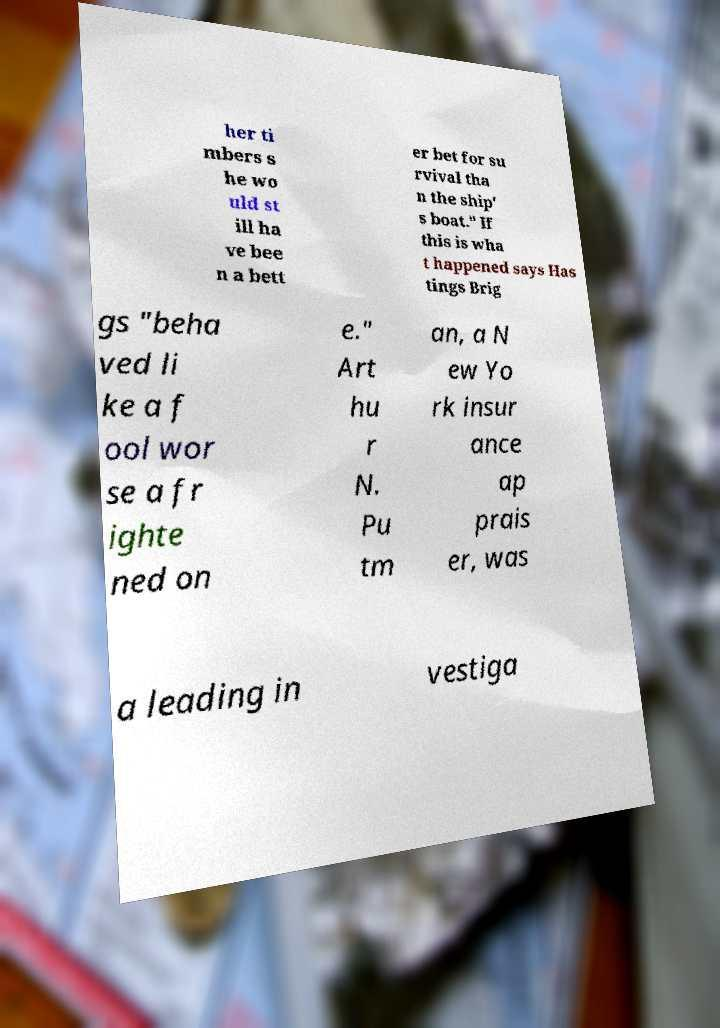What messages or text are displayed in this image? I need them in a readable, typed format. her ti mbers s he wo uld st ill ha ve bee n a bett er bet for su rvival tha n the ship' s boat." If this is wha t happened says Has tings Brig gs "beha ved li ke a f ool wor se a fr ighte ned on e." Art hu r N. Pu tm an, a N ew Yo rk insur ance ap prais er, was a leading in vestiga 